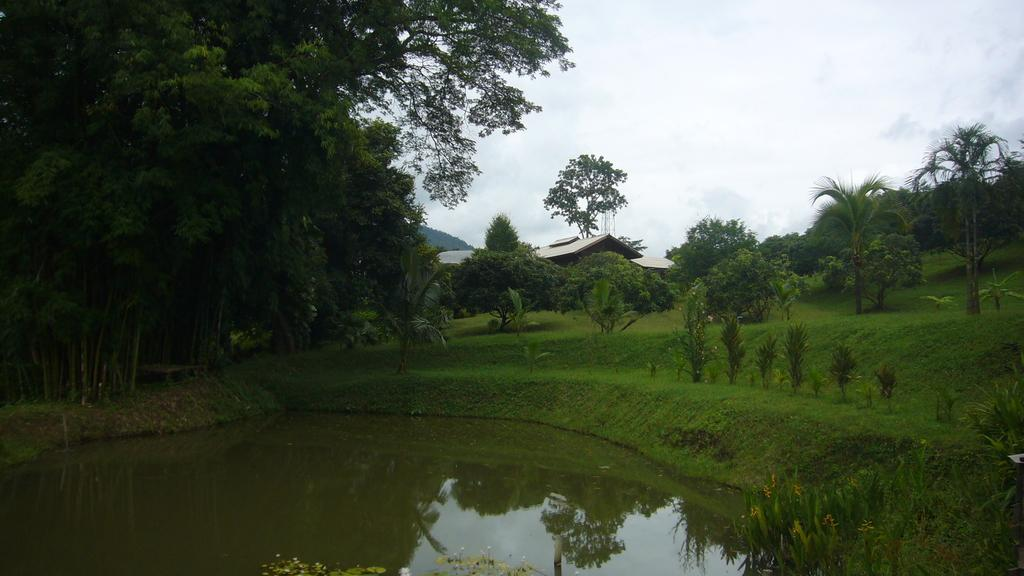What is located in front of the image? There is water in front of the image. What can be seen in the middle of the image? There are trees and grass in the middle of the image. What is visible in the background of the image? The sky and buildings are visible in the background of the image. Can you see any wilderness in the image? The term "wilderness" is not mentioned in the provided facts, and there is no indication of wilderness in the image. How many apples are on the trees in the image? There is no mention of apples or trees with fruit in the provided facts, and therefore we cannot determine the number of apples in the image. 